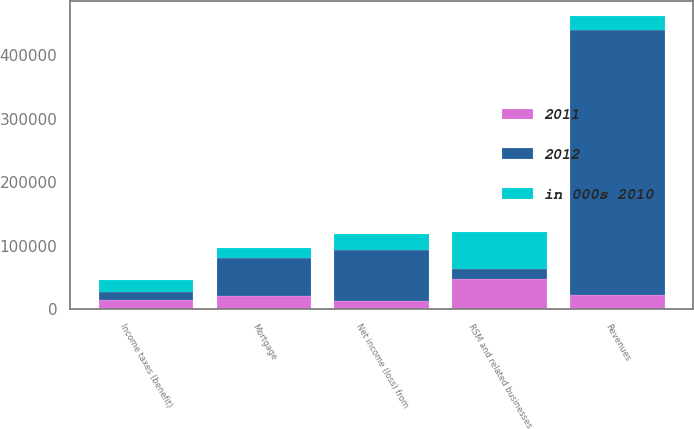Convert chart to OTSL. <chart><loc_0><loc_0><loc_500><loc_500><stacked_bar_chart><ecel><fcel>Revenues<fcel>RSM and related businesses<fcel>Mortgage<fcel>Income taxes (benefit)<fcel>Net income (loss) from<nl><fcel>2012<fcel>417168<fcel>14441<fcel>59702<fcel>13329<fcel>80036<nl><fcel>2011<fcel>22381.5<fcel>48021<fcel>20644<fcel>13814<fcel>13563<nl><fcel>in 000s 2010<fcel>22381.5<fcel>59492<fcel>16449<fcel>18924<fcel>24119<nl></chart> 